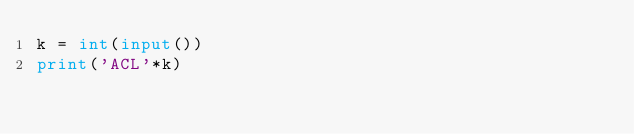Convert code to text. <code><loc_0><loc_0><loc_500><loc_500><_Python_>k = int(input())
print('ACL'*k)</code> 